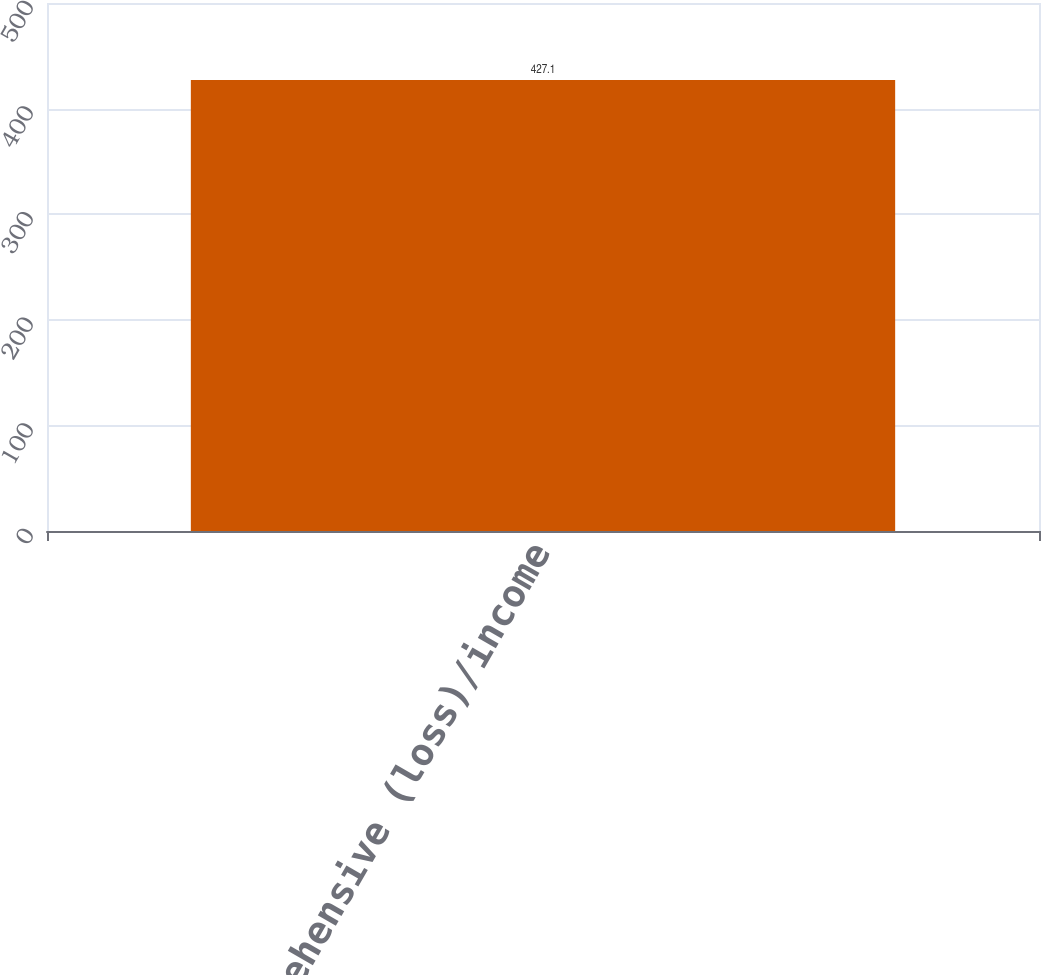Convert chart to OTSL. <chart><loc_0><loc_0><loc_500><loc_500><bar_chart><fcel>Comprehensive (loss)/income<nl><fcel>427.1<nl></chart> 